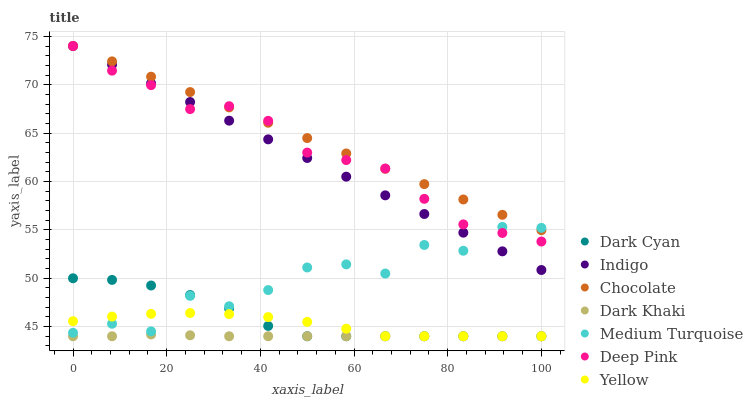Does Dark Khaki have the minimum area under the curve?
Answer yes or no. Yes. Does Chocolate have the maximum area under the curve?
Answer yes or no. Yes. Does Indigo have the minimum area under the curve?
Answer yes or no. No. Does Indigo have the maximum area under the curve?
Answer yes or no. No. Is Indigo the smoothest?
Answer yes or no. Yes. Is Medium Turquoise the roughest?
Answer yes or no. Yes. Is Yellow the smoothest?
Answer yes or no. No. Is Yellow the roughest?
Answer yes or no. No. Does Yellow have the lowest value?
Answer yes or no. Yes. Does Indigo have the lowest value?
Answer yes or no. No. Does Chocolate have the highest value?
Answer yes or no. Yes. Does Yellow have the highest value?
Answer yes or no. No. Is Dark Khaki less than Chocolate?
Answer yes or no. Yes. Is Deep Pink greater than Dark Cyan?
Answer yes or no. Yes. Does Dark Khaki intersect Dark Cyan?
Answer yes or no. Yes. Is Dark Khaki less than Dark Cyan?
Answer yes or no. No. Is Dark Khaki greater than Dark Cyan?
Answer yes or no. No. Does Dark Khaki intersect Chocolate?
Answer yes or no. No. 